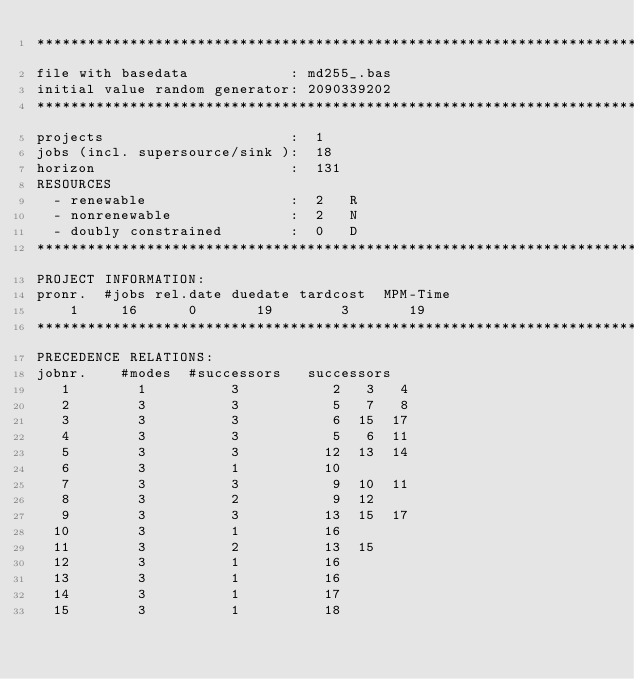<code> <loc_0><loc_0><loc_500><loc_500><_ObjectiveC_>************************************************************************
file with basedata            : md255_.bas
initial value random generator: 2090339202
************************************************************************
projects                      :  1
jobs (incl. supersource/sink ):  18
horizon                       :  131
RESOURCES
  - renewable                 :  2   R
  - nonrenewable              :  2   N
  - doubly constrained        :  0   D
************************************************************************
PROJECT INFORMATION:
pronr.  #jobs rel.date duedate tardcost  MPM-Time
    1     16      0       19        3       19
************************************************************************
PRECEDENCE RELATIONS:
jobnr.    #modes  #successors   successors
   1        1          3           2   3   4
   2        3          3           5   7   8
   3        3          3           6  15  17
   4        3          3           5   6  11
   5        3          3          12  13  14
   6        3          1          10
   7        3          3           9  10  11
   8        3          2           9  12
   9        3          3          13  15  17
  10        3          1          16
  11        3          2          13  15
  12        3          1          16
  13        3          1          16
  14        3          1          17
  15        3          1          18</code> 